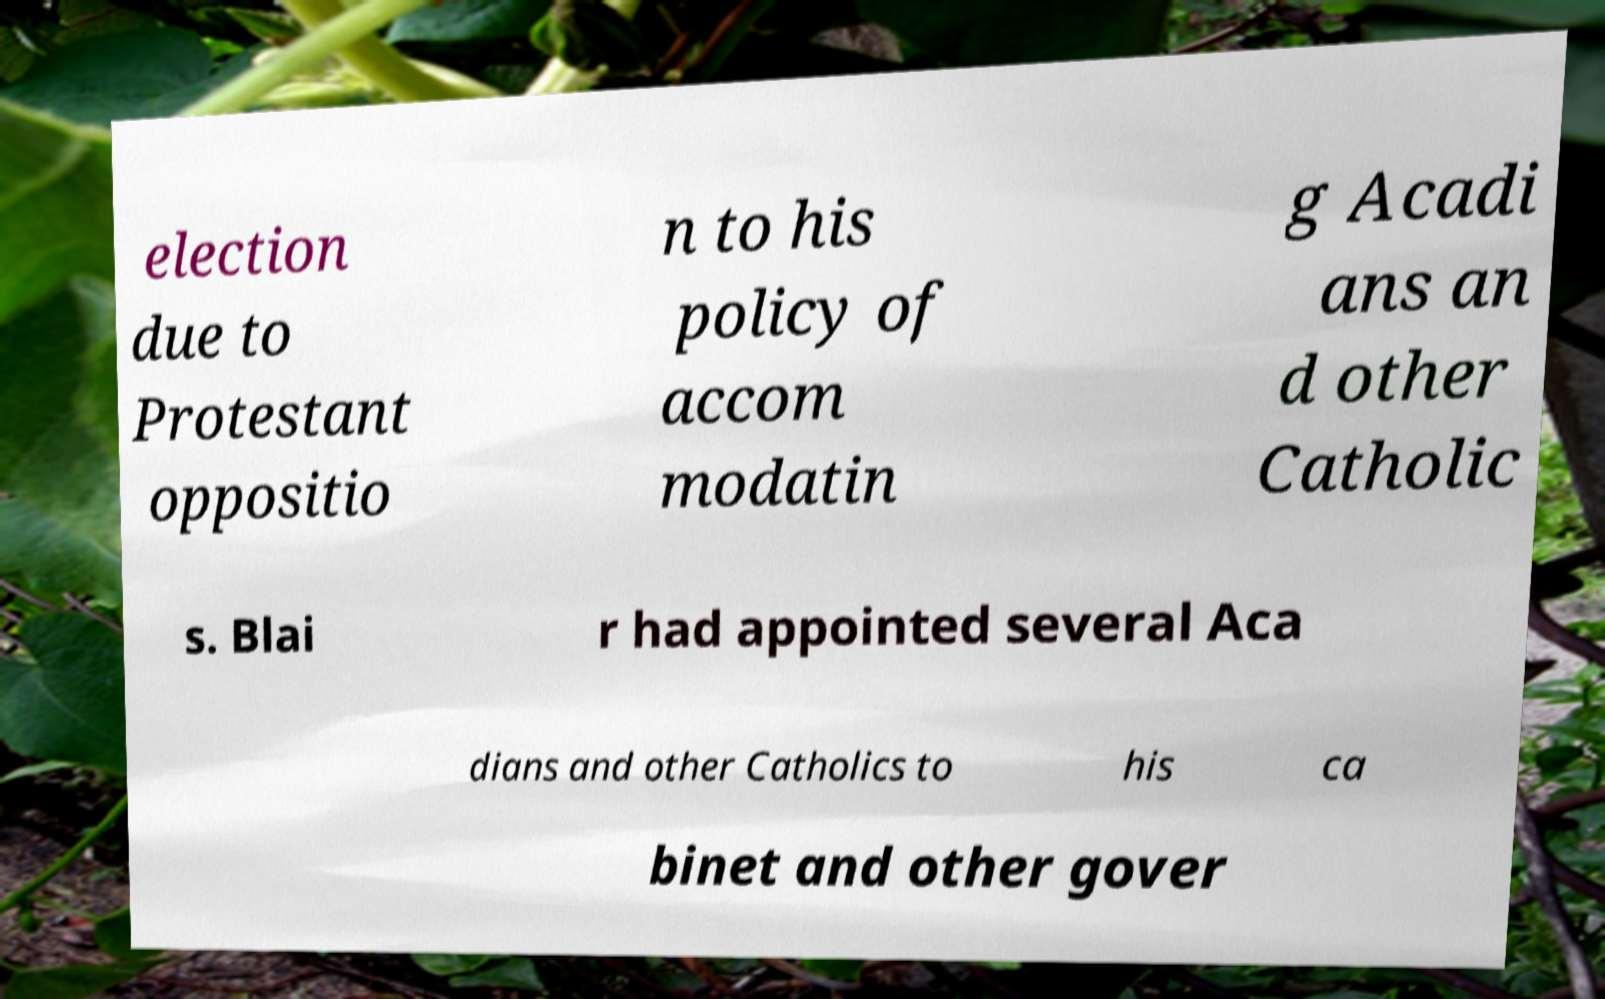Can you accurately transcribe the text from the provided image for me? election due to Protestant oppositio n to his policy of accom modatin g Acadi ans an d other Catholic s. Blai r had appointed several Aca dians and other Catholics to his ca binet and other gover 